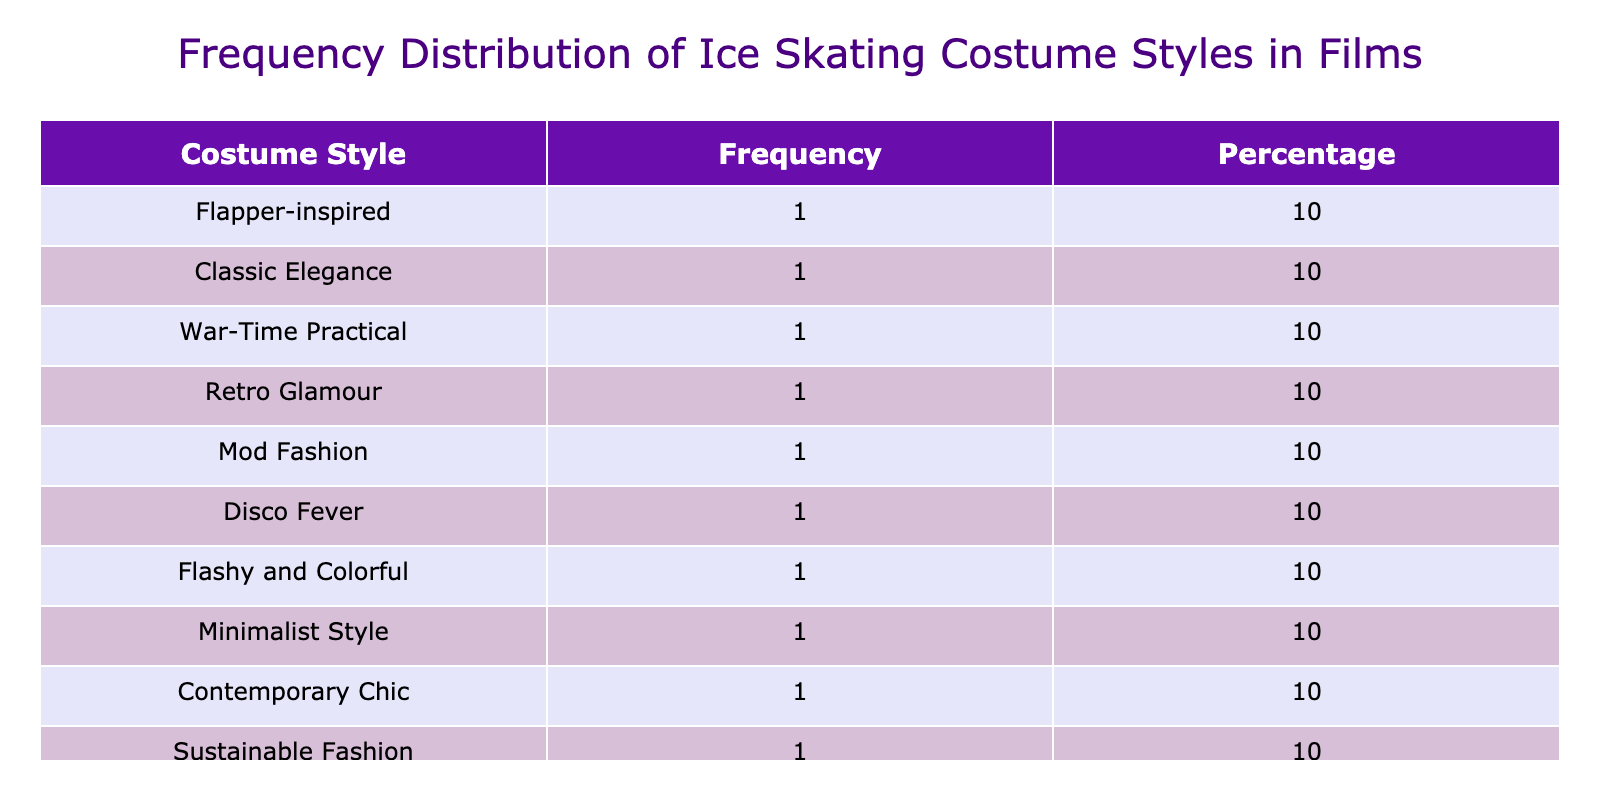What is the most frequently used ice skating costume style in films? By examining the table, we can identify the costume style with the highest frequency. Simply find the row with the highest value in the Frequency column. From the data, Flapper-inspired has the highest frequency.
Answer: Flapper-inspired How many different costume styles are listed in the table? To find the number of different costume styles, count the unique entries in the Costume Style column. There are ten distinct styles listed in the table.
Answer: 10 Which decade features the Retro Glamour costume style? Look at the Costume Style column and find "Retro Glamour." The corresponding decade in the same row indicates the answer, which is the 1950s.
Answer: 1950s Is there any costume style listed in the table from the 2000s? To answer this, check the decade column for any entry from the 2000s. The table includes "Contemporary Chic" under the 2000s, confirming the presence of a costume style from this decade.
Answer: Yes What percentage of the total costume styles does the Minimalist Style represent? First, note the frequency of Minimalist Style, which is 1. Then, find the total frequency of all styles, which sums to 10. To find the percentage: (Frequency of Minimalist Style / Total Frequency) * 100 = (1/10) * 100 = 10. Therefore, Minimalist Style represents 10% of the total.
Answer: 10% How many costume styles are associated with actresses from the 1900s? Review the decades listed in the table. The only decades before 1950 are 1920s, 1930s, and 1940s with one style each. Therefore, there are three costume styles associated with actresses from the 1900s.
Answer: 3 If we combine the frequencies of the costume styles from the 1980s and 1990s, what is the total? Identify the frequencies for the 1980s (1) and 1990s (1) costume styles. Adding these together gives us 1 + 1 = 2. Thus, the total frequency for these two decades combined is 2.
Answer: 2 Which costume style represents the lowest frequency in the table? To find the costume style with the lowest frequency, scan through the Frequency column to identify the smallest value. Both Minimalist Style and others have a frequency of 1; thus, they are effectively tied as the lowest.
Answer: Minimalist Style 